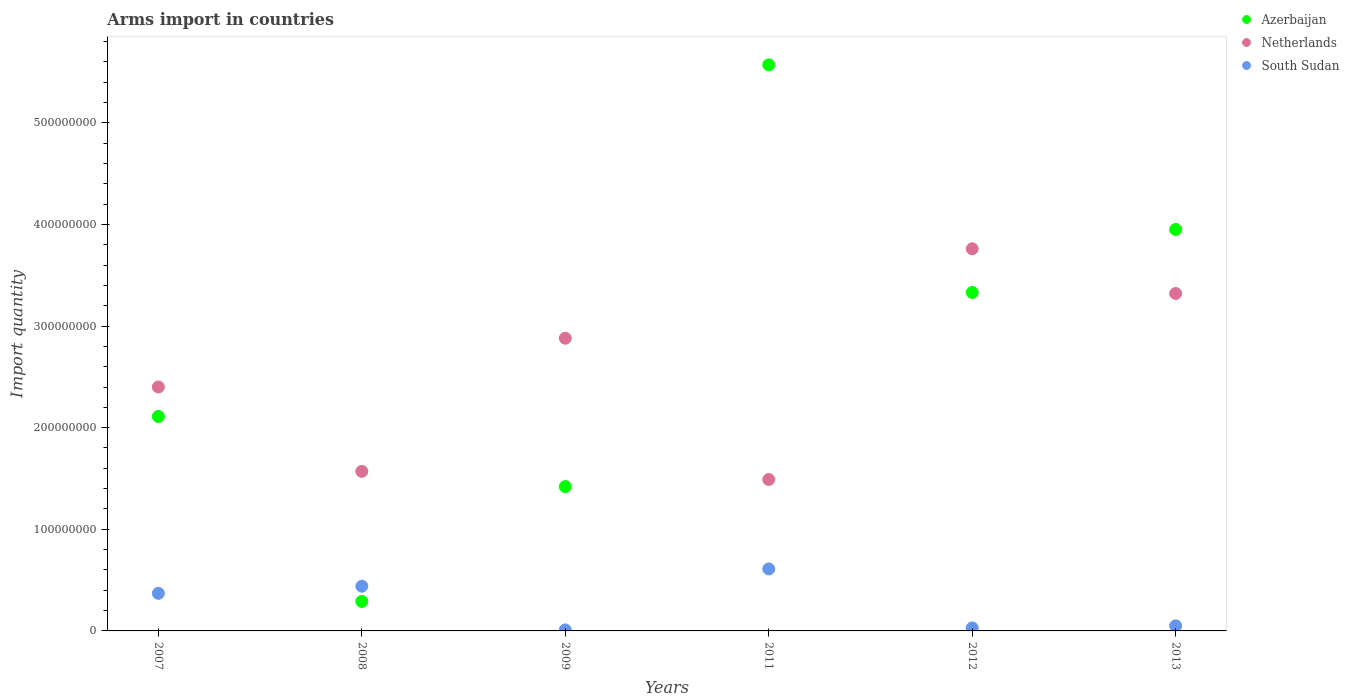Across all years, what is the maximum total arms import in Netherlands?
Your answer should be very brief. 3.76e+08. In which year was the total arms import in Azerbaijan minimum?
Make the answer very short. 2008. What is the total total arms import in Netherlands in the graph?
Offer a terse response. 1.54e+09. What is the difference between the total arms import in Netherlands in 2011 and that in 2012?
Your answer should be very brief. -2.27e+08. What is the difference between the total arms import in South Sudan in 2011 and the total arms import in Netherlands in 2013?
Your answer should be very brief. -2.71e+08. What is the average total arms import in Netherlands per year?
Provide a short and direct response. 2.57e+08. In the year 2011, what is the difference between the total arms import in Netherlands and total arms import in South Sudan?
Provide a short and direct response. 8.80e+07. In how many years, is the total arms import in South Sudan greater than 220000000?
Make the answer very short. 0. What is the ratio of the total arms import in Netherlands in 2008 to that in 2009?
Make the answer very short. 0.55. Is the total arms import in Netherlands in 2009 less than that in 2013?
Make the answer very short. Yes. What is the difference between the highest and the second highest total arms import in Azerbaijan?
Keep it short and to the point. 1.62e+08. What is the difference between the highest and the lowest total arms import in South Sudan?
Provide a short and direct response. 6.00e+07. Is the sum of the total arms import in South Sudan in 2009 and 2011 greater than the maximum total arms import in Netherlands across all years?
Make the answer very short. No. Does the total arms import in South Sudan monotonically increase over the years?
Keep it short and to the point. No. Are the values on the major ticks of Y-axis written in scientific E-notation?
Give a very brief answer. No. Does the graph contain grids?
Your answer should be compact. No. How are the legend labels stacked?
Provide a succinct answer. Vertical. What is the title of the graph?
Your answer should be compact. Arms import in countries. Does "Croatia" appear as one of the legend labels in the graph?
Your response must be concise. No. What is the label or title of the Y-axis?
Ensure brevity in your answer.  Import quantity. What is the Import quantity of Azerbaijan in 2007?
Offer a terse response. 2.11e+08. What is the Import quantity in Netherlands in 2007?
Provide a succinct answer. 2.40e+08. What is the Import quantity of South Sudan in 2007?
Offer a terse response. 3.70e+07. What is the Import quantity of Azerbaijan in 2008?
Offer a terse response. 2.90e+07. What is the Import quantity of Netherlands in 2008?
Your answer should be very brief. 1.57e+08. What is the Import quantity in South Sudan in 2008?
Offer a terse response. 4.40e+07. What is the Import quantity in Azerbaijan in 2009?
Your answer should be compact. 1.42e+08. What is the Import quantity in Netherlands in 2009?
Give a very brief answer. 2.88e+08. What is the Import quantity in South Sudan in 2009?
Your answer should be compact. 1.00e+06. What is the Import quantity of Azerbaijan in 2011?
Keep it short and to the point. 5.57e+08. What is the Import quantity of Netherlands in 2011?
Ensure brevity in your answer.  1.49e+08. What is the Import quantity in South Sudan in 2011?
Ensure brevity in your answer.  6.10e+07. What is the Import quantity in Azerbaijan in 2012?
Ensure brevity in your answer.  3.33e+08. What is the Import quantity in Netherlands in 2012?
Ensure brevity in your answer.  3.76e+08. What is the Import quantity of Azerbaijan in 2013?
Give a very brief answer. 3.95e+08. What is the Import quantity of Netherlands in 2013?
Offer a very short reply. 3.32e+08. What is the Import quantity in South Sudan in 2013?
Keep it short and to the point. 5.00e+06. Across all years, what is the maximum Import quantity in Azerbaijan?
Keep it short and to the point. 5.57e+08. Across all years, what is the maximum Import quantity of Netherlands?
Your response must be concise. 3.76e+08. Across all years, what is the maximum Import quantity in South Sudan?
Your response must be concise. 6.10e+07. Across all years, what is the minimum Import quantity of Azerbaijan?
Your response must be concise. 2.90e+07. Across all years, what is the minimum Import quantity of Netherlands?
Keep it short and to the point. 1.49e+08. Across all years, what is the minimum Import quantity of South Sudan?
Offer a terse response. 1.00e+06. What is the total Import quantity of Azerbaijan in the graph?
Provide a short and direct response. 1.67e+09. What is the total Import quantity in Netherlands in the graph?
Make the answer very short. 1.54e+09. What is the total Import quantity of South Sudan in the graph?
Offer a terse response. 1.51e+08. What is the difference between the Import quantity of Azerbaijan in 2007 and that in 2008?
Give a very brief answer. 1.82e+08. What is the difference between the Import quantity in Netherlands in 2007 and that in 2008?
Offer a very short reply. 8.30e+07. What is the difference between the Import quantity in South Sudan in 2007 and that in 2008?
Your answer should be very brief. -7.00e+06. What is the difference between the Import quantity of Azerbaijan in 2007 and that in 2009?
Provide a short and direct response. 6.90e+07. What is the difference between the Import quantity in Netherlands in 2007 and that in 2009?
Give a very brief answer. -4.80e+07. What is the difference between the Import quantity in South Sudan in 2007 and that in 2009?
Provide a short and direct response. 3.60e+07. What is the difference between the Import quantity of Azerbaijan in 2007 and that in 2011?
Make the answer very short. -3.46e+08. What is the difference between the Import quantity in Netherlands in 2007 and that in 2011?
Make the answer very short. 9.10e+07. What is the difference between the Import quantity of South Sudan in 2007 and that in 2011?
Provide a short and direct response. -2.40e+07. What is the difference between the Import quantity of Azerbaijan in 2007 and that in 2012?
Provide a succinct answer. -1.22e+08. What is the difference between the Import quantity of Netherlands in 2007 and that in 2012?
Ensure brevity in your answer.  -1.36e+08. What is the difference between the Import quantity of South Sudan in 2007 and that in 2012?
Your answer should be very brief. 3.40e+07. What is the difference between the Import quantity in Azerbaijan in 2007 and that in 2013?
Give a very brief answer. -1.84e+08. What is the difference between the Import quantity of Netherlands in 2007 and that in 2013?
Offer a very short reply. -9.20e+07. What is the difference between the Import quantity in South Sudan in 2007 and that in 2013?
Offer a very short reply. 3.20e+07. What is the difference between the Import quantity of Azerbaijan in 2008 and that in 2009?
Ensure brevity in your answer.  -1.13e+08. What is the difference between the Import quantity in Netherlands in 2008 and that in 2009?
Your response must be concise. -1.31e+08. What is the difference between the Import quantity in South Sudan in 2008 and that in 2009?
Ensure brevity in your answer.  4.30e+07. What is the difference between the Import quantity in Azerbaijan in 2008 and that in 2011?
Your answer should be compact. -5.28e+08. What is the difference between the Import quantity in South Sudan in 2008 and that in 2011?
Give a very brief answer. -1.70e+07. What is the difference between the Import quantity of Azerbaijan in 2008 and that in 2012?
Your answer should be compact. -3.04e+08. What is the difference between the Import quantity in Netherlands in 2008 and that in 2012?
Keep it short and to the point. -2.19e+08. What is the difference between the Import quantity of South Sudan in 2008 and that in 2012?
Provide a succinct answer. 4.10e+07. What is the difference between the Import quantity of Azerbaijan in 2008 and that in 2013?
Your answer should be compact. -3.66e+08. What is the difference between the Import quantity of Netherlands in 2008 and that in 2013?
Your response must be concise. -1.75e+08. What is the difference between the Import quantity of South Sudan in 2008 and that in 2013?
Ensure brevity in your answer.  3.90e+07. What is the difference between the Import quantity of Azerbaijan in 2009 and that in 2011?
Your answer should be compact. -4.15e+08. What is the difference between the Import quantity of Netherlands in 2009 and that in 2011?
Provide a succinct answer. 1.39e+08. What is the difference between the Import quantity in South Sudan in 2009 and that in 2011?
Ensure brevity in your answer.  -6.00e+07. What is the difference between the Import quantity in Azerbaijan in 2009 and that in 2012?
Your response must be concise. -1.91e+08. What is the difference between the Import quantity of Netherlands in 2009 and that in 2012?
Your response must be concise. -8.80e+07. What is the difference between the Import quantity in South Sudan in 2009 and that in 2012?
Provide a succinct answer. -2.00e+06. What is the difference between the Import quantity of Azerbaijan in 2009 and that in 2013?
Make the answer very short. -2.53e+08. What is the difference between the Import quantity of Netherlands in 2009 and that in 2013?
Provide a succinct answer. -4.40e+07. What is the difference between the Import quantity of South Sudan in 2009 and that in 2013?
Make the answer very short. -4.00e+06. What is the difference between the Import quantity in Azerbaijan in 2011 and that in 2012?
Offer a very short reply. 2.24e+08. What is the difference between the Import quantity of Netherlands in 2011 and that in 2012?
Your response must be concise. -2.27e+08. What is the difference between the Import quantity in South Sudan in 2011 and that in 2012?
Your answer should be compact. 5.80e+07. What is the difference between the Import quantity in Azerbaijan in 2011 and that in 2013?
Make the answer very short. 1.62e+08. What is the difference between the Import quantity in Netherlands in 2011 and that in 2013?
Offer a terse response. -1.83e+08. What is the difference between the Import quantity in South Sudan in 2011 and that in 2013?
Ensure brevity in your answer.  5.60e+07. What is the difference between the Import quantity of Azerbaijan in 2012 and that in 2013?
Give a very brief answer. -6.20e+07. What is the difference between the Import quantity in Netherlands in 2012 and that in 2013?
Offer a very short reply. 4.40e+07. What is the difference between the Import quantity in Azerbaijan in 2007 and the Import quantity in Netherlands in 2008?
Make the answer very short. 5.40e+07. What is the difference between the Import quantity in Azerbaijan in 2007 and the Import quantity in South Sudan in 2008?
Give a very brief answer. 1.67e+08. What is the difference between the Import quantity in Netherlands in 2007 and the Import quantity in South Sudan in 2008?
Your response must be concise. 1.96e+08. What is the difference between the Import quantity in Azerbaijan in 2007 and the Import quantity in Netherlands in 2009?
Ensure brevity in your answer.  -7.70e+07. What is the difference between the Import quantity of Azerbaijan in 2007 and the Import quantity of South Sudan in 2009?
Offer a terse response. 2.10e+08. What is the difference between the Import quantity in Netherlands in 2007 and the Import quantity in South Sudan in 2009?
Keep it short and to the point. 2.39e+08. What is the difference between the Import quantity of Azerbaijan in 2007 and the Import quantity of Netherlands in 2011?
Make the answer very short. 6.20e+07. What is the difference between the Import quantity in Azerbaijan in 2007 and the Import quantity in South Sudan in 2011?
Your answer should be very brief. 1.50e+08. What is the difference between the Import quantity in Netherlands in 2007 and the Import quantity in South Sudan in 2011?
Give a very brief answer. 1.79e+08. What is the difference between the Import quantity in Azerbaijan in 2007 and the Import quantity in Netherlands in 2012?
Keep it short and to the point. -1.65e+08. What is the difference between the Import quantity in Azerbaijan in 2007 and the Import quantity in South Sudan in 2012?
Your response must be concise. 2.08e+08. What is the difference between the Import quantity of Netherlands in 2007 and the Import quantity of South Sudan in 2012?
Offer a terse response. 2.37e+08. What is the difference between the Import quantity of Azerbaijan in 2007 and the Import quantity of Netherlands in 2013?
Your response must be concise. -1.21e+08. What is the difference between the Import quantity of Azerbaijan in 2007 and the Import quantity of South Sudan in 2013?
Give a very brief answer. 2.06e+08. What is the difference between the Import quantity of Netherlands in 2007 and the Import quantity of South Sudan in 2013?
Ensure brevity in your answer.  2.35e+08. What is the difference between the Import quantity in Azerbaijan in 2008 and the Import quantity in Netherlands in 2009?
Provide a short and direct response. -2.59e+08. What is the difference between the Import quantity in Azerbaijan in 2008 and the Import quantity in South Sudan in 2009?
Provide a succinct answer. 2.80e+07. What is the difference between the Import quantity of Netherlands in 2008 and the Import quantity of South Sudan in 2009?
Provide a short and direct response. 1.56e+08. What is the difference between the Import quantity of Azerbaijan in 2008 and the Import quantity of Netherlands in 2011?
Make the answer very short. -1.20e+08. What is the difference between the Import quantity in Azerbaijan in 2008 and the Import quantity in South Sudan in 2011?
Your answer should be compact. -3.20e+07. What is the difference between the Import quantity of Netherlands in 2008 and the Import quantity of South Sudan in 2011?
Your response must be concise. 9.60e+07. What is the difference between the Import quantity in Azerbaijan in 2008 and the Import quantity in Netherlands in 2012?
Offer a very short reply. -3.47e+08. What is the difference between the Import quantity of Azerbaijan in 2008 and the Import quantity of South Sudan in 2012?
Give a very brief answer. 2.60e+07. What is the difference between the Import quantity of Netherlands in 2008 and the Import quantity of South Sudan in 2012?
Make the answer very short. 1.54e+08. What is the difference between the Import quantity of Azerbaijan in 2008 and the Import quantity of Netherlands in 2013?
Ensure brevity in your answer.  -3.03e+08. What is the difference between the Import quantity of Azerbaijan in 2008 and the Import quantity of South Sudan in 2013?
Your answer should be very brief. 2.40e+07. What is the difference between the Import quantity of Netherlands in 2008 and the Import quantity of South Sudan in 2013?
Make the answer very short. 1.52e+08. What is the difference between the Import quantity in Azerbaijan in 2009 and the Import quantity in Netherlands in 2011?
Your answer should be very brief. -7.00e+06. What is the difference between the Import quantity in Azerbaijan in 2009 and the Import quantity in South Sudan in 2011?
Provide a succinct answer. 8.10e+07. What is the difference between the Import quantity in Netherlands in 2009 and the Import quantity in South Sudan in 2011?
Keep it short and to the point. 2.27e+08. What is the difference between the Import quantity of Azerbaijan in 2009 and the Import quantity of Netherlands in 2012?
Make the answer very short. -2.34e+08. What is the difference between the Import quantity in Azerbaijan in 2009 and the Import quantity in South Sudan in 2012?
Provide a short and direct response. 1.39e+08. What is the difference between the Import quantity in Netherlands in 2009 and the Import quantity in South Sudan in 2012?
Provide a short and direct response. 2.85e+08. What is the difference between the Import quantity in Azerbaijan in 2009 and the Import quantity in Netherlands in 2013?
Make the answer very short. -1.90e+08. What is the difference between the Import quantity of Azerbaijan in 2009 and the Import quantity of South Sudan in 2013?
Your response must be concise. 1.37e+08. What is the difference between the Import quantity in Netherlands in 2009 and the Import quantity in South Sudan in 2013?
Keep it short and to the point. 2.83e+08. What is the difference between the Import quantity in Azerbaijan in 2011 and the Import quantity in Netherlands in 2012?
Your response must be concise. 1.81e+08. What is the difference between the Import quantity in Azerbaijan in 2011 and the Import quantity in South Sudan in 2012?
Give a very brief answer. 5.54e+08. What is the difference between the Import quantity in Netherlands in 2011 and the Import quantity in South Sudan in 2012?
Ensure brevity in your answer.  1.46e+08. What is the difference between the Import quantity in Azerbaijan in 2011 and the Import quantity in Netherlands in 2013?
Your answer should be very brief. 2.25e+08. What is the difference between the Import quantity in Azerbaijan in 2011 and the Import quantity in South Sudan in 2013?
Your response must be concise. 5.52e+08. What is the difference between the Import quantity in Netherlands in 2011 and the Import quantity in South Sudan in 2013?
Offer a very short reply. 1.44e+08. What is the difference between the Import quantity in Azerbaijan in 2012 and the Import quantity in South Sudan in 2013?
Provide a succinct answer. 3.28e+08. What is the difference between the Import quantity of Netherlands in 2012 and the Import quantity of South Sudan in 2013?
Provide a short and direct response. 3.71e+08. What is the average Import quantity of Azerbaijan per year?
Make the answer very short. 2.78e+08. What is the average Import quantity in Netherlands per year?
Offer a terse response. 2.57e+08. What is the average Import quantity in South Sudan per year?
Offer a terse response. 2.52e+07. In the year 2007, what is the difference between the Import quantity in Azerbaijan and Import quantity in Netherlands?
Give a very brief answer. -2.90e+07. In the year 2007, what is the difference between the Import quantity in Azerbaijan and Import quantity in South Sudan?
Your answer should be very brief. 1.74e+08. In the year 2007, what is the difference between the Import quantity in Netherlands and Import quantity in South Sudan?
Offer a very short reply. 2.03e+08. In the year 2008, what is the difference between the Import quantity of Azerbaijan and Import quantity of Netherlands?
Offer a terse response. -1.28e+08. In the year 2008, what is the difference between the Import quantity of Azerbaijan and Import quantity of South Sudan?
Your response must be concise. -1.50e+07. In the year 2008, what is the difference between the Import quantity in Netherlands and Import quantity in South Sudan?
Your answer should be very brief. 1.13e+08. In the year 2009, what is the difference between the Import quantity in Azerbaijan and Import quantity in Netherlands?
Offer a terse response. -1.46e+08. In the year 2009, what is the difference between the Import quantity of Azerbaijan and Import quantity of South Sudan?
Keep it short and to the point. 1.41e+08. In the year 2009, what is the difference between the Import quantity in Netherlands and Import quantity in South Sudan?
Provide a short and direct response. 2.87e+08. In the year 2011, what is the difference between the Import quantity of Azerbaijan and Import quantity of Netherlands?
Your answer should be compact. 4.08e+08. In the year 2011, what is the difference between the Import quantity in Azerbaijan and Import quantity in South Sudan?
Offer a very short reply. 4.96e+08. In the year 2011, what is the difference between the Import quantity of Netherlands and Import quantity of South Sudan?
Ensure brevity in your answer.  8.80e+07. In the year 2012, what is the difference between the Import quantity of Azerbaijan and Import quantity of Netherlands?
Offer a very short reply. -4.30e+07. In the year 2012, what is the difference between the Import quantity in Azerbaijan and Import quantity in South Sudan?
Give a very brief answer. 3.30e+08. In the year 2012, what is the difference between the Import quantity of Netherlands and Import quantity of South Sudan?
Your answer should be very brief. 3.73e+08. In the year 2013, what is the difference between the Import quantity of Azerbaijan and Import quantity of Netherlands?
Offer a terse response. 6.30e+07. In the year 2013, what is the difference between the Import quantity in Azerbaijan and Import quantity in South Sudan?
Make the answer very short. 3.90e+08. In the year 2013, what is the difference between the Import quantity of Netherlands and Import quantity of South Sudan?
Give a very brief answer. 3.27e+08. What is the ratio of the Import quantity of Azerbaijan in 2007 to that in 2008?
Make the answer very short. 7.28. What is the ratio of the Import quantity in Netherlands in 2007 to that in 2008?
Offer a terse response. 1.53. What is the ratio of the Import quantity of South Sudan in 2007 to that in 2008?
Offer a very short reply. 0.84. What is the ratio of the Import quantity of Azerbaijan in 2007 to that in 2009?
Give a very brief answer. 1.49. What is the ratio of the Import quantity of Netherlands in 2007 to that in 2009?
Make the answer very short. 0.83. What is the ratio of the Import quantity in South Sudan in 2007 to that in 2009?
Offer a very short reply. 37. What is the ratio of the Import quantity in Azerbaijan in 2007 to that in 2011?
Your answer should be very brief. 0.38. What is the ratio of the Import quantity in Netherlands in 2007 to that in 2011?
Offer a terse response. 1.61. What is the ratio of the Import quantity in South Sudan in 2007 to that in 2011?
Provide a short and direct response. 0.61. What is the ratio of the Import quantity of Azerbaijan in 2007 to that in 2012?
Your answer should be very brief. 0.63. What is the ratio of the Import quantity in Netherlands in 2007 to that in 2012?
Offer a terse response. 0.64. What is the ratio of the Import quantity of South Sudan in 2007 to that in 2012?
Provide a short and direct response. 12.33. What is the ratio of the Import quantity of Azerbaijan in 2007 to that in 2013?
Keep it short and to the point. 0.53. What is the ratio of the Import quantity of Netherlands in 2007 to that in 2013?
Keep it short and to the point. 0.72. What is the ratio of the Import quantity of South Sudan in 2007 to that in 2013?
Ensure brevity in your answer.  7.4. What is the ratio of the Import quantity in Azerbaijan in 2008 to that in 2009?
Your answer should be very brief. 0.2. What is the ratio of the Import quantity in Netherlands in 2008 to that in 2009?
Your answer should be compact. 0.55. What is the ratio of the Import quantity of Azerbaijan in 2008 to that in 2011?
Give a very brief answer. 0.05. What is the ratio of the Import quantity of Netherlands in 2008 to that in 2011?
Offer a terse response. 1.05. What is the ratio of the Import quantity in South Sudan in 2008 to that in 2011?
Your answer should be compact. 0.72. What is the ratio of the Import quantity of Azerbaijan in 2008 to that in 2012?
Provide a short and direct response. 0.09. What is the ratio of the Import quantity in Netherlands in 2008 to that in 2012?
Give a very brief answer. 0.42. What is the ratio of the Import quantity of South Sudan in 2008 to that in 2012?
Keep it short and to the point. 14.67. What is the ratio of the Import quantity of Azerbaijan in 2008 to that in 2013?
Offer a very short reply. 0.07. What is the ratio of the Import quantity of Netherlands in 2008 to that in 2013?
Make the answer very short. 0.47. What is the ratio of the Import quantity of South Sudan in 2008 to that in 2013?
Offer a terse response. 8.8. What is the ratio of the Import quantity of Azerbaijan in 2009 to that in 2011?
Provide a succinct answer. 0.25. What is the ratio of the Import quantity in Netherlands in 2009 to that in 2011?
Your answer should be very brief. 1.93. What is the ratio of the Import quantity of South Sudan in 2009 to that in 2011?
Give a very brief answer. 0.02. What is the ratio of the Import quantity of Azerbaijan in 2009 to that in 2012?
Your response must be concise. 0.43. What is the ratio of the Import quantity of Netherlands in 2009 to that in 2012?
Your answer should be very brief. 0.77. What is the ratio of the Import quantity of South Sudan in 2009 to that in 2012?
Offer a terse response. 0.33. What is the ratio of the Import quantity of Azerbaijan in 2009 to that in 2013?
Your answer should be compact. 0.36. What is the ratio of the Import quantity in Netherlands in 2009 to that in 2013?
Offer a very short reply. 0.87. What is the ratio of the Import quantity in South Sudan in 2009 to that in 2013?
Provide a succinct answer. 0.2. What is the ratio of the Import quantity in Azerbaijan in 2011 to that in 2012?
Give a very brief answer. 1.67. What is the ratio of the Import quantity of Netherlands in 2011 to that in 2012?
Offer a very short reply. 0.4. What is the ratio of the Import quantity in South Sudan in 2011 to that in 2012?
Offer a very short reply. 20.33. What is the ratio of the Import quantity of Azerbaijan in 2011 to that in 2013?
Keep it short and to the point. 1.41. What is the ratio of the Import quantity in Netherlands in 2011 to that in 2013?
Provide a short and direct response. 0.45. What is the ratio of the Import quantity in Azerbaijan in 2012 to that in 2013?
Give a very brief answer. 0.84. What is the ratio of the Import quantity in Netherlands in 2012 to that in 2013?
Make the answer very short. 1.13. What is the ratio of the Import quantity in South Sudan in 2012 to that in 2013?
Make the answer very short. 0.6. What is the difference between the highest and the second highest Import quantity of Azerbaijan?
Your answer should be very brief. 1.62e+08. What is the difference between the highest and the second highest Import quantity in Netherlands?
Give a very brief answer. 4.40e+07. What is the difference between the highest and the second highest Import quantity in South Sudan?
Provide a short and direct response. 1.70e+07. What is the difference between the highest and the lowest Import quantity in Azerbaijan?
Make the answer very short. 5.28e+08. What is the difference between the highest and the lowest Import quantity of Netherlands?
Your response must be concise. 2.27e+08. What is the difference between the highest and the lowest Import quantity of South Sudan?
Give a very brief answer. 6.00e+07. 